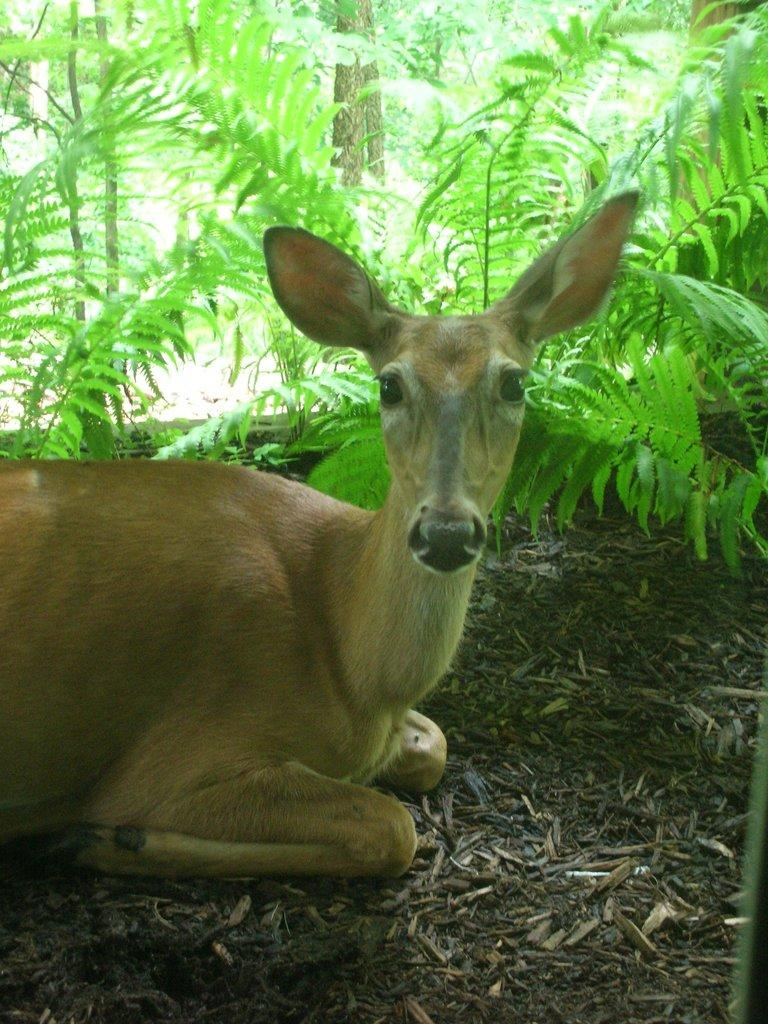What is the main subject of the image? There is a deer in the center of the image. Can you describe the deer's appearance? The deer is brown in color. What can be seen in the background of the image? There are plants visible in the background of the image. What type of linen is draped over the deer's mouth in the image? There is no linen or any object covering the deer's mouth in the image. 